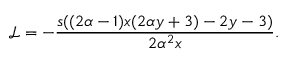<formula> <loc_0><loc_0><loc_500><loc_500>\mathcal { L } = - \frac { s ( ( 2 \alpha - 1 ) x ( 2 \alpha y + 3 ) - 2 y - 3 ) } { 2 \alpha ^ { 2 } x } .</formula> 